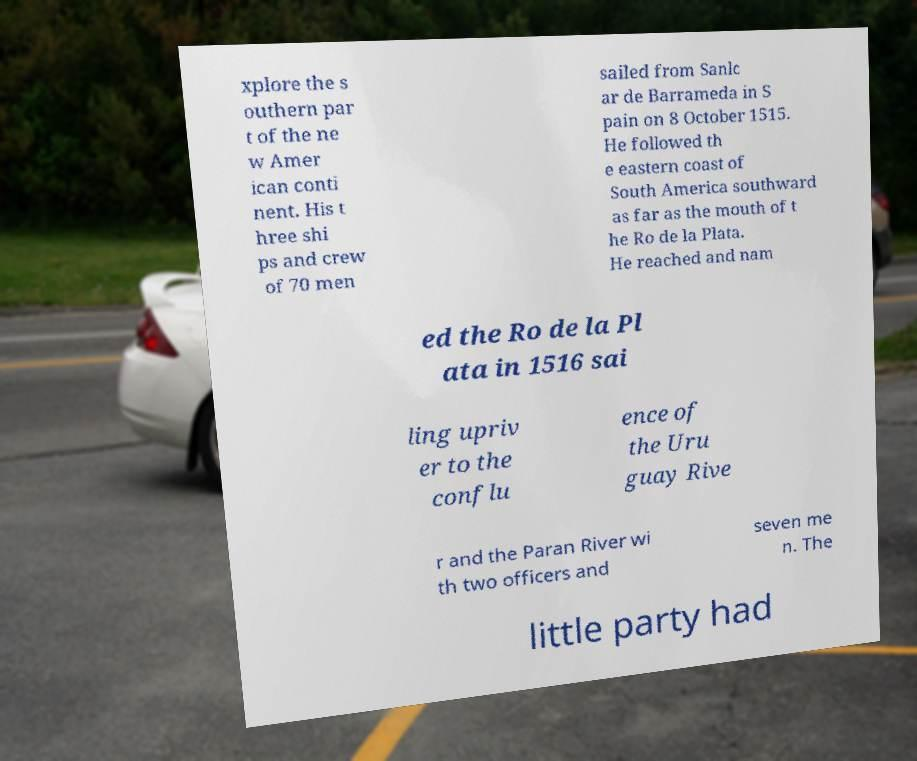Can you read and provide the text displayed in the image?This photo seems to have some interesting text. Can you extract and type it out for me? xplore the s outhern par t of the ne w Amer ican conti nent. His t hree shi ps and crew of 70 men sailed from Sanlc ar de Barrameda in S pain on 8 October 1515. He followed th e eastern coast of South America southward as far as the mouth of t he Ro de la Plata. He reached and nam ed the Ro de la Pl ata in 1516 sai ling upriv er to the conflu ence of the Uru guay Rive r and the Paran River wi th two officers and seven me n. The little party had 